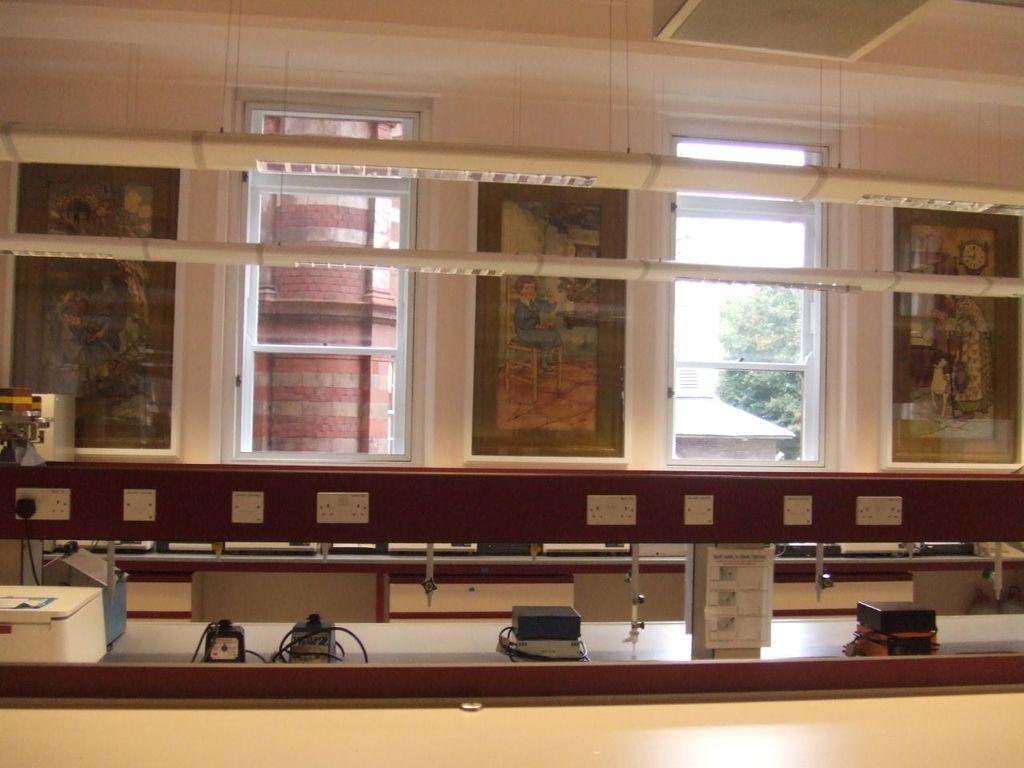In one or two sentences, can you explain what this image depicts? In this image we can see some devices which are placed on the surface. We can also see the switchboards, frames on a wall, windows and a roof with some ceiling lights. On the backside we can see some trees. 